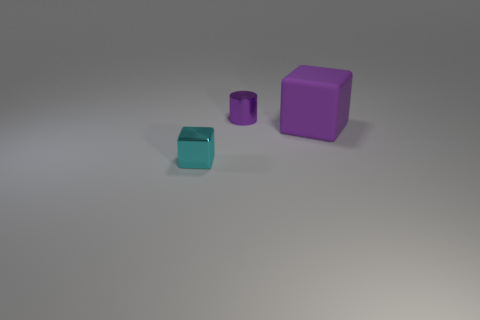Add 3 small blocks. How many objects exist? 6 Subtract all cubes. How many objects are left? 1 Add 3 small cyan things. How many small cyan things exist? 4 Subtract 0 cyan cylinders. How many objects are left? 3 Subtract all cyan objects. Subtract all big purple things. How many objects are left? 1 Add 3 big purple objects. How many big purple objects are left? 4 